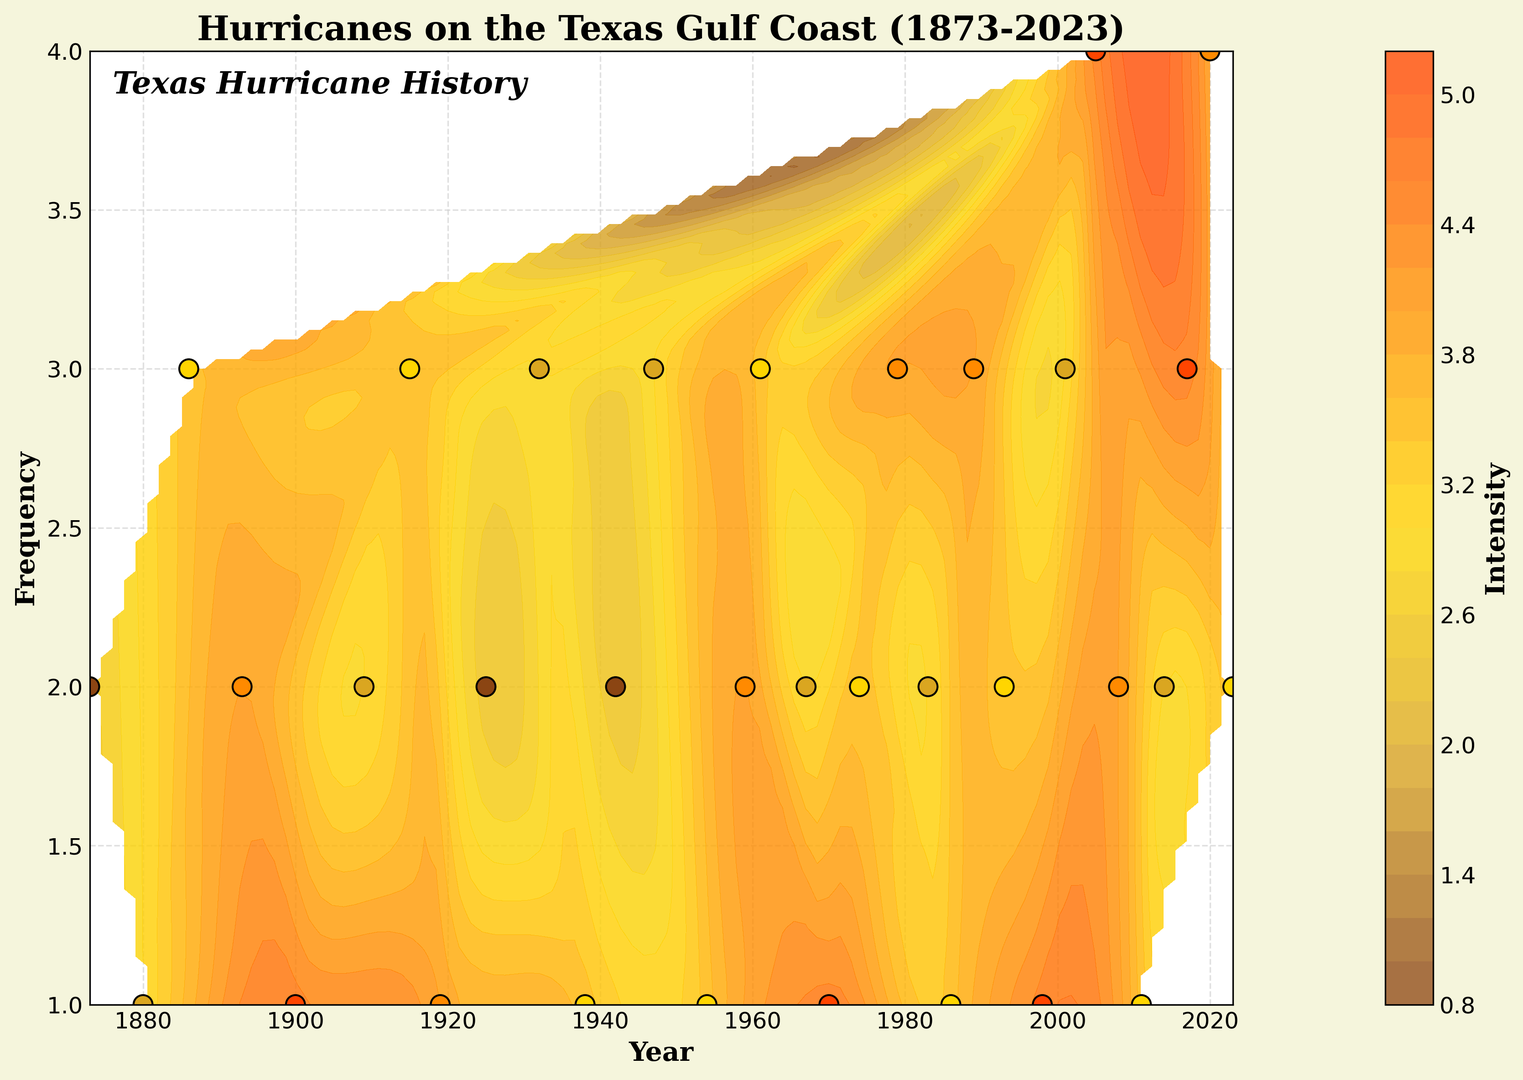What is the highest hurricane intensity recorded on the Texas Gulf Coast in the last 150 years? By examining the contour plot's color scale and looking for the brightest color (likely red), we can identify the regions with the highest intensity markers. The highest intensity indicated is close to the value of 4.5.
Answer: 4.5 What year had the highest hurricane intensity with more than one occurrence? Check the contour plot and color-coded intensity markers where the occurrence frequency is more than 1. The year 2005 has a frequency greater than 1 and the highest intensity of 4.5.
Answer: 2005 How does the frequency and intensity of hurricanes in 2005 compare to 2020? Look at the contour regions around 2005 and 2020. Both 2005 and 2020 have high intensities indicated by brighter colors, but 2020 has a higher frequency marked by four occurrences compared to three in 2005.
Answer: 2020: High frequency (4), High intensity (4.0); 2005: Moderate frequency (3), High intensity (4.5) During which decade did we see a notable increase in hurricane frequency and intensity? Analyze the pattern over time by looking at the color density and frequency patterns. Observe that around the 2000s (2000-2010), intensities and frequencies both increased, evident in the brighter colored areas and denser frequency markers.
Answer: 2000-2010 What period experienced the lowest frequency yet saw significant hurricane intensities? Identify the periods with the least frequent but high hurricane intensities. The 1880s is such a period, evidenced by the fewer, yet intense occurrences marked brighter around the year 1886.
Answer: 1880s Compare hurricane activity between the early 1900s (1900-1910) and the late 2010s (2010-2020). Inspect the contour areas corresponding to the early 1900s and late 2010s. The early 1900s show moderate frequency and intensities, whereas the late 2010s show higher frequencies and intensities, indicated by more frequent and brighter markers.
Answer: 2010s: Higher frequency, higher intensity; 1900s: Moderate frequency, moderate intensity Which year had the highest hurricane frequency with moderate intensity ranges (between 3.0 and 4.0)? Scan for years with the highest frequency markers where the contour colors correspond to moderate intensities. The year 2020 stands out with a frequency of 4 and an intensity around 4.0.
Answer: 2020 What trend can be seen in the hurricane frequencies and intensities from 1900 to 1950? From 1900 to 1950, observe the trend in the contour and colors. There is a moderate increase in frequency with intensity values that remain relatively steady within moderate ranges.
Answer: Moderate increase in frequency, steady moderate intensities 